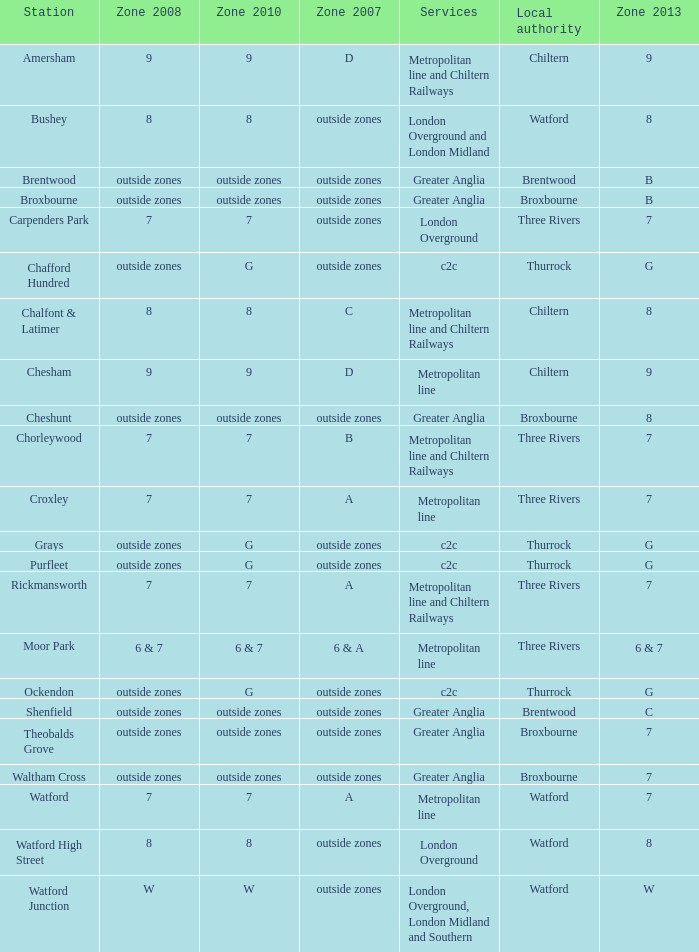Which Zone 2008 has Services of greater anglia, and a Station of cheshunt? Outside zones. 